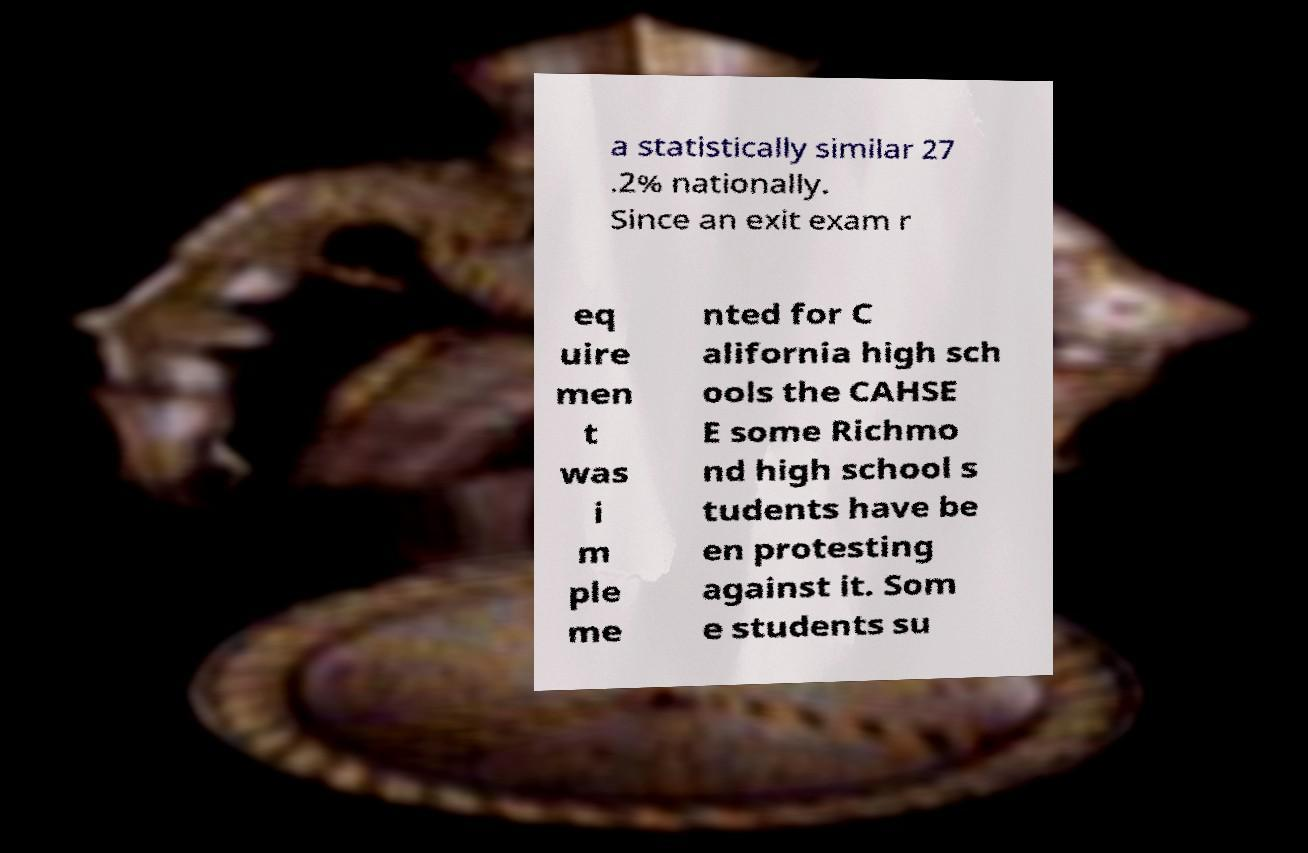Please identify and transcribe the text found in this image. a statistically similar 27 .2% nationally. Since an exit exam r eq uire men t was i m ple me nted for C alifornia high sch ools the CAHSE E some Richmo nd high school s tudents have be en protesting against it. Som e students su 